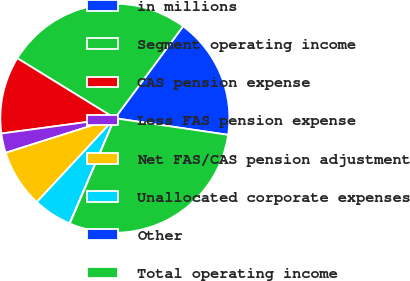Convert chart. <chart><loc_0><loc_0><loc_500><loc_500><pie_chart><fcel>in millions<fcel>Segment operating income<fcel>CAS pension expense<fcel>Less FAS pension expense<fcel>Net FAS/CAS pension adjustment<fcel>Unallocated corporate expenses<fcel>Other<fcel>Total operating income<nl><fcel>17.16%<fcel>26.4%<fcel>10.91%<fcel>2.75%<fcel>8.19%<fcel>5.47%<fcel>0.03%<fcel>29.12%<nl></chart> 